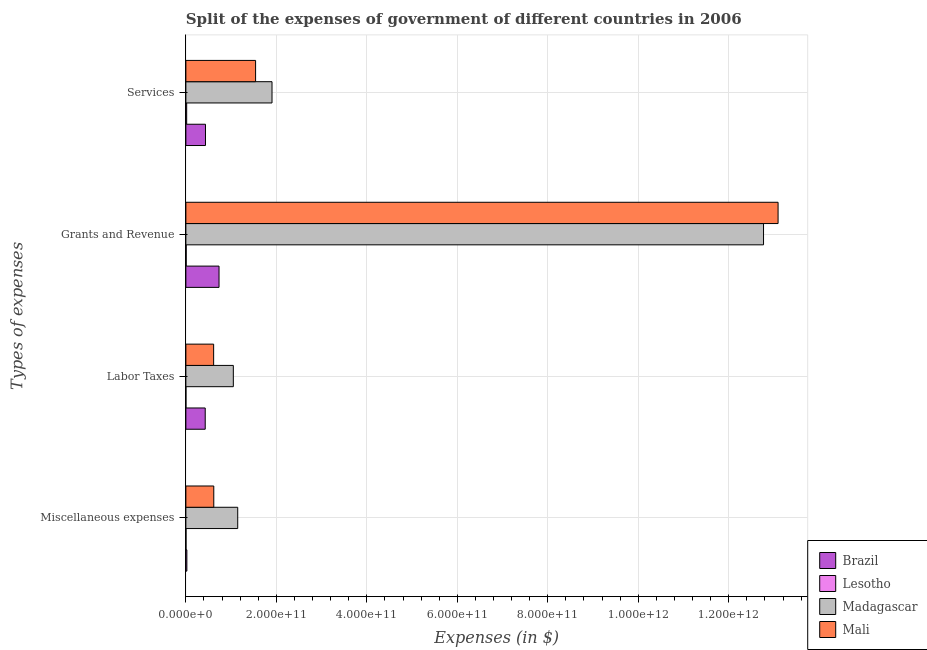How many groups of bars are there?
Keep it short and to the point. 4. Are the number of bars per tick equal to the number of legend labels?
Give a very brief answer. Yes. Are the number of bars on each tick of the Y-axis equal?
Provide a succinct answer. Yes. How many bars are there on the 3rd tick from the top?
Provide a short and direct response. 4. What is the label of the 2nd group of bars from the top?
Your answer should be compact. Grants and Revenue. What is the amount spent on services in Mali?
Keep it short and to the point. 1.54e+11. Across all countries, what is the maximum amount spent on services?
Your response must be concise. 1.90e+11. Across all countries, what is the minimum amount spent on services?
Give a very brief answer. 1.76e+09. In which country was the amount spent on miscellaneous expenses maximum?
Your answer should be very brief. Madagascar. In which country was the amount spent on miscellaneous expenses minimum?
Ensure brevity in your answer.  Lesotho. What is the total amount spent on services in the graph?
Your answer should be compact. 3.90e+11. What is the difference between the amount spent on services in Madagascar and that in Brazil?
Provide a succinct answer. 1.47e+11. What is the difference between the amount spent on miscellaneous expenses in Brazil and the amount spent on services in Lesotho?
Your response must be concise. 4.16e+08. What is the average amount spent on labor taxes per country?
Offer a terse response. 5.23e+1. What is the difference between the amount spent on grants and revenue and amount spent on miscellaneous expenses in Brazil?
Your answer should be compact. 7.11e+1. What is the ratio of the amount spent on services in Brazil to that in Madagascar?
Offer a very short reply. 0.23. Is the amount spent on services in Lesotho less than that in Madagascar?
Provide a succinct answer. Yes. Is the difference between the amount spent on miscellaneous expenses in Madagascar and Mali greater than the difference between the amount spent on services in Madagascar and Mali?
Give a very brief answer. Yes. What is the difference between the highest and the second highest amount spent on miscellaneous expenses?
Your answer should be compact. 5.29e+1. What is the difference between the highest and the lowest amount spent on services?
Give a very brief answer. 1.89e+11. In how many countries, is the amount spent on grants and revenue greater than the average amount spent on grants and revenue taken over all countries?
Offer a terse response. 2. Is the sum of the amount spent on labor taxes in Brazil and Madagascar greater than the maximum amount spent on services across all countries?
Your answer should be compact. No. What does the 3rd bar from the bottom in Grants and Revenue represents?
Give a very brief answer. Madagascar. How many countries are there in the graph?
Keep it short and to the point. 4. What is the difference between two consecutive major ticks on the X-axis?
Offer a very short reply. 2.00e+11. Are the values on the major ticks of X-axis written in scientific E-notation?
Your response must be concise. Yes. Does the graph contain any zero values?
Your response must be concise. No. How many legend labels are there?
Offer a terse response. 4. What is the title of the graph?
Your response must be concise. Split of the expenses of government of different countries in 2006. What is the label or title of the X-axis?
Provide a succinct answer. Expenses (in $). What is the label or title of the Y-axis?
Keep it short and to the point. Types of expenses. What is the Expenses (in $) of Brazil in Miscellaneous expenses?
Provide a short and direct response. 2.18e+09. What is the Expenses (in $) in Lesotho in Miscellaneous expenses?
Keep it short and to the point. 2.85e+08. What is the Expenses (in $) of Madagascar in Miscellaneous expenses?
Ensure brevity in your answer.  1.15e+11. What is the Expenses (in $) of Mali in Miscellaneous expenses?
Your response must be concise. 6.17e+1. What is the Expenses (in $) in Brazil in Labor Taxes?
Give a very brief answer. 4.28e+1. What is the Expenses (in $) in Lesotho in Labor Taxes?
Offer a terse response. 7.48e+07. What is the Expenses (in $) in Madagascar in Labor Taxes?
Provide a short and direct response. 1.05e+11. What is the Expenses (in $) in Mali in Labor Taxes?
Give a very brief answer. 6.14e+1. What is the Expenses (in $) of Brazil in Grants and Revenue?
Ensure brevity in your answer.  7.33e+1. What is the Expenses (in $) in Lesotho in Grants and Revenue?
Your answer should be very brief. 6.74e+08. What is the Expenses (in $) of Madagascar in Grants and Revenue?
Provide a short and direct response. 1.28e+12. What is the Expenses (in $) of Mali in Grants and Revenue?
Provide a succinct answer. 1.31e+12. What is the Expenses (in $) in Brazil in Services?
Make the answer very short. 4.33e+1. What is the Expenses (in $) in Lesotho in Services?
Keep it short and to the point. 1.76e+09. What is the Expenses (in $) of Madagascar in Services?
Your response must be concise. 1.90e+11. What is the Expenses (in $) of Mali in Services?
Make the answer very short. 1.54e+11. Across all Types of expenses, what is the maximum Expenses (in $) of Brazil?
Provide a succinct answer. 7.33e+1. Across all Types of expenses, what is the maximum Expenses (in $) of Lesotho?
Give a very brief answer. 1.76e+09. Across all Types of expenses, what is the maximum Expenses (in $) in Madagascar?
Ensure brevity in your answer.  1.28e+12. Across all Types of expenses, what is the maximum Expenses (in $) in Mali?
Your answer should be compact. 1.31e+12. Across all Types of expenses, what is the minimum Expenses (in $) in Brazil?
Provide a short and direct response. 2.18e+09. Across all Types of expenses, what is the minimum Expenses (in $) of Lesotho?
Your response must be concise. 7.48e+07. Across all Types of expenses, what is the minimum Expenses (in $) of Madagascar?
Make the answer very short. 1.05e+11. Across all Types of expenses, what is the minimum Expenses (in $) in Mali?
Offer a terse response. 6.14e+1. What is the total Expenses (in $) of Brazil in the graph?
Your response must be concise. 1.62e+11. What is the total Expenses (in $) in Lesotho in the graph?
Keep it short and to the point. 2.80e+09. What is the total Expenses (in $) in Madagascar in the graph?
Ensure brevity in your answer.  1.69e+12. What is the total Expenses (in $) in Mali in the graph?
Make the answer very short. 1.59e+12. What is the difference between the Expenses (in $) of Brazil in Miscellaneous expenses and that in Labor Taxes?
Offer a terse response. -4.06e+1. What is the difference between the Expenses (in $) in Lesotho in Miscellaneous expenses and that in Labor Taxes?
Your response must be concise. 2.11e+08. What is the difference between the Expenses (in $) of Madagascar in Miscellaneous expenses and that in Labor Taxes?
Your answer should be compact. 9.70e+09. What is the difference between the Expenses (in $) in Mali in Miscellaneous expenses and that in Labor Taxes?
Your answer should be compact. 3.42e+08. What is the difference between the Expenses (in $) of Brazil in Miscellaneous expenses and that in Grants and Revenue?
Keep it short and to the point. -7.11e+1. What is the difference between the Expenses (in $) in Lesotho in Miscellaneous expenses and that in Grants and Revenue?
Provide a short and direct response. -3.88e+08. What is the difference between the Expenses (in $) of Madagascar in Miscellaneous expenses and that in Grants and Revenue?
Offer a terse response. -1.16e+12. What is the difference between the Expenses (in $) of Mali in Miscellaneous expenses and that in Grants and Revenue?
Ensure brevity in your answer.  -1.25e+12. What is the difference between the Expenses (in $) of Brazil in Miscellaneous expenses and that in Services?
Offer a terse response. -4.11e+1. What is the difference between the Expenses (in $) of Lesotho in Miscellaneous expenses and that in Services?
Provide a short and direct response. -1.48e+09. What is the difference between the Expenses (in $) of Madagascar in Miscellaneous expenses and that in Services?
Offer a terse response. -7.58e+1. What is the difference between the Expenses (in $) in Mali in Miscellaneous expenses and that in Services?
Your answer should be compact. -9.24e+1. What is the difference between the Expenses (in $) in Brazil in Labor Taxes and that in Grants and Revenue?
Provide a short and direct response. -3.05e+1. What is the difference between the Expenses (in $) of Lesotho in Labor Taxes and that in Grants and Revenue?
Your response must be concise. -5.99e+08. What is the difference between the Expenses (in $) in Madagascar in Labor Taxes and that in Grants and Revenue?
Give a very brief answer. -1.17e+12. What is the difference between the Expenses (in $) of Mali in Labor Taxes and that in Grants and Revenue?
Ensure brevity in your answer.  -1.25e+12. What is the difference between the Expenses (in $) of Brazil in Labor Taxes and that in Services?
Your answer should be very brief. -5.74e+08. What is the difference between the Expenses (in $) of Lesotho in Labor Taxes and that in Services?
Offer a very short reply. -1.69e+09. What is the difference between the Expenses (in $) in Madagascar in Labor Taxes and that in Services?
Offer a very short reply. -8.55e+1. What is the difference between the Expenses (in $) of Mali in Labor Taxes and that in Services?
Keep it short and to the point. -9.28e+1. What is the difference between the Expenses (in $) of Brazil in Grants and Revenue and that in Services?
Your response must be concise. 3.00e+1. What is the difference between the Expenses (in $) in Lesotho in Grants and Revenue and that in Services?
Offer a very short reply. -1.09e+09. What is the difference between the Expenses (in $) in Madagascar in Grants and Revenue and that in Services?
Your answer should be compact. 1.09e+12. What is the difference between the Expenses (in $) of Mali in Grants and Revenue and that in Services?
Your response must be concise. 1.15e+12. What is the difference between the Expenses (in $) in Brazil in Miscellaneous expenses and the Expenses (in $) in Lesotho in Labor Taxes?
Provide a succinct answer. 2.10e+09. What is the difference between the Expenses (in $) of Brazil in Miscellaneous expenses and the Expenses (in $) of Madagascar in Labor Taxes?
Your answer should be very brief. -1.03e+11. What is the difference between the Expenses (in $) in Brazil in Miscellaneous expenses and the Expenses (in $) in Mali in Labor Taxes?
Offer a very short reply. -5.92e+1. What is the difference between the Expenses (in $) of Lesotho in Miscellaneous expenses and the Expenses (in $) of Madagascar in Labor Taxes?
Provide a succinct answer. -1.05e+11. What is the difference between the Expenses (in $) in Lesotho in Miscellaneous expenses and the Expenses (in $) in Mali in Labor Taxes?
Provide a succinct answer. -6.11e+1. What is the difference between the Expenses (in $) of Madagascar in Miscellaneous expenses and the Expenses (in $) of Mali in Labor Taxes?
Ensure brevity in your answer.  5.32e+1. What is the difference between the Expenses (in $) in Brazil in Miscellaneous expenses and the Expenses (in $) in Lesotho in Grants and Revenue?
Give a very brief answer. 1.50e+09. What is the difference between the Expenses (in $) in Brazil in Miscellaneous expenses and the Expenses (in $) in Madagascar in Grants and Revenue?
Your answer should be compact. -1.27e+12. What is the difference between the Expenses (in $) of Brazil in Miscellaneous expenses and the Expenses (in $) of Mali in Grants and Revenue?
Offer a terse response. -1.31e+12. What is the difference between the Expenses (in $) in Lesotho in Miscellaneous expenses and the Expenses (in $) in Madagascar in Grants and Revenue?
Provide a short and direct response. -1.28e+12. What is the difference between the Expenses (in $) of Lesotho in Miscellaneous expenses and the Expenses (in $) of Mali in Grants and Revenue?
Give a very brief answer. -1.31e+12. What is the difference between the Expenses (in $) of Madagascar in Miscellaneous expenses and the Expenses (in $) of Mali in Grants and Revenue?
Make the answer very short. -1.19e+12. What is the difference between the Expenses (in $) in Brazil in Miscellaneous expenses and the Expenses (in $) in Lesotho in Services?
Provide a short and direct response. 4.16e+08. What is the difference between the Expenses (in $) of Brazil in Miscellaneous expenses and the Expenses (in $) of Madagascar in Services?
Your answer should be very brief. -1.88e+11. What is the difference between the Expenses (in $) of Brazil in Miscellaneous expenses and the Expenses (in $) of Mali in Services?
Your answer should be very brief. -1.52e+11. What is the difference between the Expenses (in $) of Lesotho in Miscellaneous expenses and the Expenses (in $) of Madagascar in Services?
Offer a terse response. -1.90e+11. What is the difference between the Expenses (in $) of Lesotho in Miscellaneous expenses and the Expenses (in $) of Mali in Services?
Provide a short and direct response. -1.54e+11. What is the difference between the Expenses (in $) in Madagascar in Miscellaneous expenses and the Expenses (in $) in Mali in Services?
Ensure brevity in your answer.  -3.95e+1. What is the difference between the Expenses (in $) of Brazil in Labor Taxes and the Expenses (in $) of Lesotho in Grants and Revenue?
Ensure brevity in your answer.  4.21e+1. What is the difference between the Expenses (in $) of Brazil in Labor Taxes and the Expenses (in $) of Madagascar in Grants and Revenue?
Offer a very short reply. -1.23e+12. What is the difference between the Expenses (in $) in Brazil in Labor Taxes and the Expenses (in $) in Mali in Grants and Revenue?
Your response must be concise. -1.27e+12. What is the difference between the Expenses (in $) of Lesotho in Labor Taxes and the Expenses (in $) of Madagascar in Grants and Revenue?
Provide a succinct answer. -1.28e+12. What is the difference between the Expenses (in $) of Lesotho in Labor Taxes and the Expenses (in $) of Mali in Grants and Revenue?
Keep it short and to the point. -1.31e+12. What is the difference between the Expenses (in $) in Madagascar in Labor Taxes and the Expenses (in $) in Mali in Grants and Revenue?
Ensure brevity in your answer.  -1.20e+12. What is the difference between the Expenses (in $) of Brazil in Labor Taxes and the Expenses (in $) of Lesotho in Services?
Offer a terse response. 4.10e+1. What is the difference between the Expenses (in $) in Brazil in Labor Taxes and the Expenses (in $) in Madagascar in Services?
Give a very brief answer. -1.48e+11. What is the difference between the Expenses (in $) of Brazil in Labor Taxes and the Expenses (in $) of Mali in Services?
Offer a terse response. -1.11e+11. What is the difference between the Expenses (in $) of Lesotho in Labor Taxes and the Expenses (in $) of Madagascar in Services?
Ensure brevity in your answer.  -1.90e+11. What is the difference between the Expenses (in $) in Lesotho in Labor Taxes and the Expenses (in $) in Mali in Services?
Offer a very short reply. -1.54e+11. What is the difference between the Expenses (in $) in Madagascar in Labor Taxes and the Expenses (in $) in Mali in Services?
Provide a succinct answer. -4.92e+1. What is the difference between the Expenses (in $) in Brazil in Grants and Revenue and the Expenses (in $) in Lesotho in Services?
Your answer should be compact. 7.15e+1. What is the difference between the Expenses (in $) in Brazil in Grants and Revenue and the Expenses (in $) in Madagascar in Services?
Offer a terse response. -1.17e+11. What is the difference between the Expenses (in $) in Brazil in Grants and Revenue and the Expenses (in $) in Mali in Services?
Give a very brief answer. -8.08e+1. What is the difference between the Expenses (in $) of Lesotho in Grants and Revenue and the Expenses (in $) of Madagascar in Services?
Your answer should be compact. -1.90e+11. What is the difference between the Expenses (in $) in Lesotho in Grants and Revenue and the Expenses (in $) in Mali in Services?
Offer a terse response. -1.53e+11. What is the difference between the Expenses (in $) of Madagascar in Grants and Revenue and the Expenses (in $) of Mali in Services?
Provide a short and direct response. 1.12e+12. What is the average Expenses (in $) of Brazil per Types of expenses?
Ensure brevity in your answer.  4.04e+1. What is the average Expenses (in $) of Lesotho per Types of expenses?
Your answer should be very brief. 6.99e+08. What is the average Expenses (in $) of Madagascar per Types of expenses?
Give a very brief answer. 4.22e+11. What is the average Expenses (in $) of Mali per Types of expenses?
Give a very brief answer. 3.97e+11. What is the difference between the Expenses (in $) in Brazil and Expenses (in $) in Lesotho in Miscellaneous expenses?
Your response must be concise. 1.89e+09. What is the difference between the Expenses (in $) of Brazil and Expenses (in $) of Madagascar in Miscellaneous expenses?
Give a very brief answer. -1.12e+11. What is the difference between the Expenses (in $) of Brazil and Expenses (in $) of Mali in Miscellaneous expenses?
Provide a short and direct response. -5.95e+1. What is the difference between the Expenses (in $) of Lesotho and Expenses (in $) of Madagascar in Miscellaneous expenses?
Your response must be concise. -1.14e+11. What is the difference between the Expenses (in $) of Lesotho and Expenses (in $) of Mali in Miscellaneous expenses?
Provide a short and direct response. -6.14e+1. What is the difference between the Expenses (in $) in Madagascar and Expenses (in $) in Mali in Miscellaneous expenses?
Offer a very short reply. 5.29e+1. What is the difference between the Expenses (in $) in Brazil and Expenses (in $) in Lesotho in Labor Taxes?
Your answer should be compact. 4.27e+1. What is the difference between the Expenses (in $) in Brazil and Expenses (in $) in Madagascar in Labor Taxes?
Your answer should be very brief. -6.21e+1. What is the difference between the Expenses (in $) of Brazil and Expenses (in $) of Mali in Labor Taxes?
Make the answer very short. -1.86e+1. What is the difference between the Expenses (in $) in Lesotho and Expenses (in $) in Madagascar in Labor Taxes?
Offer a very short reply. -1.05e+11. What is the difference between the Expenses (in $) in Lesotho and Expenses (in $) in Mali in Labor Taxes?
Your answer should be very brief. -6.13e+1. What is the difference between the Expenses (in $) of Madagascar and Expenses (in $) of Mali in Labor Taxes?
Offer a terse response. 4.35e+1. What is the difference between the Expenses (in $) in Brazil and Expenses (in $) in Lesotho in Grants and Revenue?
Keep it short and to the point. 7.26e+1. What is the difference between the Expenses (in $) in Brazil and Expenses (in $) in Madagascar in Grants and Revenue?
Offer a very short reply. -1.20e+12. What is the difference between the Expenses (in $) in Brazil and Expenses (in $) in Mali in Grants and Revenue?
Offer a very short reply. -1.24e+12. What is the difference between the Expenses (in $) of Lesotho and Expenses (in $) of Madagascar in Grants and Revenue?
Provide a succinct answer. -1.28e+12. What is the difference between the Expenses (in $) in Lesotho and Expenses (in $) in Mali in Grants and Revenue?
Give a very brief answer. -1.31e+12. What is the difference between the Expenses (in $) of Madagascar and Expenses (in $) of Mali in Grants and Revenue?
Give a very brief answer. -3.22e+1. What is the difference between the Expenses (in $) in Brazil and Expenses (in $) in Lesotho in Services?
Offer a very short reply. 4.16e+1. What is the difference between the Expenses (in $) in Brazil and Expenses (in $) in Madagascar in Services?
Ensure brevity in your answer.  -1.47e+11. What is the difference between the Expenses (in $) of Brazil and Expenses (in $) of Mali in Services?
Make the answer very short. -1.11e+11. What is the difference between the Expenses (in $) of Lesotho and Expenses (in $) of Madagascar in Services?
Ensure brevity in your answer.  -1.89e+11. What is the difference between the Expenses (in $) of Lesotho and Expenses (in $) of Mali in Services?
Your response must be concise. -1.52e+11. What is the difference between the Expenses (in $) of Madagascar and Expenses (in $) of Mali in Services?
Make the answer very short. 3.63e+1. What is the ratio of the Expenses (in $) in Brazil in Miscellaneous expenses to that in Labor Taxes?
Make the answer very short. 0.05. What is the ratio of the Expenses (in $) of Lesotho in Miscellaneous expenses to that in Labor Taxes?
Ensure brevity in your answer.  3.82. What is the ratio of the Expenses (in $) in Madagascar in Miscellaneous expenses to that in Labor Taxes?
Your response must be concise. 1.09. What is the ratio of the Expenses (in $) in Mali in Miscellaneous expenses to that in Labor Taxes?
Your answer should be compact. 1.01. What is the ratio of the Expenses (in $) in Brazil in Miscellaneous expenses to that in Grants and Revenue?
Make the answer very short. 0.03. What is the ratio of the Expenses (in $) in Lesotho in Miscellaneous expenses to that in Grants and Revenue?
Make the answer very short. 0.42. What is the ratio of the Expenses (in $) in Madagascar in Miscellaneous expenses to that in Grants and Revenue?
Make the answer very short. 0.09. What is the ratio of the Expenses (in $) of Mali in Miscellaneous expenses to that in Grants and Revenue?
Offer a very short reply. 0.05. What is the ratio of the Expenses (in $) in Brazil in Miscellaneous expenses to that in Services?
Make the answer very short. 0.05. What is the ratio of the Expenses (in $) of Lesotho in Miscellaneous expenses to that in Services?
Provide a short and direct response. 0.16. What is the ratio of the Expenses (in $) of Madagascar in Miscellaneous expenses to that in Services?
Provide a short and direct response. 0.6. What is the ratio of the Expenses (in $) of Mali in Miscellaneous expenses to that in Services?
Offer a very short reply. 0.4. What is the ratio of the Expenses (in $) of Brazil in Labor Taxes to that in Grants and Revenue?
Make the answer very short. 0.58. What is the ratio of the Expenses (in $) in Lesotho in Labor Taxes to that in Grants and Revenue?
Your answer should be very brief. 0.11. What is the ratio of the Expenses (in $) in Madagascar in Labor Taxes to that in Grants and Revenue?
Give a very brief answer. 0.08. What is the ratio of the Expenses (in $) in Mali in Labor Taxes to that in Grants and Revenue?
Make the answer very short. 0.05. What is the ratio of the Expenses (in $) in Brazil in Labor Taxes to that in Services?
Provide a short and direct response. 0.99. What is the ratio of the Expenses (in $) in Lesotho in Labor Taxes to that in Services?
Keep it short and to the point. 0.04. What is the ratio of the Expenses (in $) of Madagascar in Labor Taxes to that in Services?
Offer a terse response. 0.55. What is the ratio of the Expenses (in $) of Mali in Labor Taxes to that in Services?
Make the answer very short. 0.4. What is the ratio of the Expenses (in $) in Brazil in Grants and Revenue to that in Services?
Make the answer very short. 1.69. What is the ratio of the Expenses (in $) of Lesotho in Grants and Revenue to that in Services?
Your answer should be very brief. 0.38. What is the ratio of the Expenses (in $) in Madagascar in Grants and Revenue to that in Services?
Offer a very short reply. 6.71. What is the ratio of the Expenses (in $) of Mali in Grants and Revenue to that in Services?
Your response must be concise. 8.49. What is the difference between the highest and the second highest Expenses (in $) of Brazil?
Keep it short and to the point. 3.00e+1. What is the difference between the highest and the second highest Expenses (in $) of Lesotho?
Provide a short and direct response. 1.09e+09. What is the difference between the highest and the second highest Expenses (in $) of Madagascar?
Ensure brevity in your answer.  1.09e+12. What is the difference between the highest and the second highest Expenses (in $) of Mali?
Offer a very short reply. 1.15e+12. What is the difference between the highest and the lowest Expenses (in $) in Brazil?
Give a very brief answer. 7.11e+1. What is the difference between the highest and the lowest Expenses (in $) in Lesotho?
Offer a terse response. 1.69e+09. What is the difference between the highest and the lowest Expenses (in $) of Madagascar?
Provide a short and direct response. 1.17e+12. What is the difference between the highest and the lowest Expenses (in $) in Mali?
Your answer should be compact. 1.25e+12. 